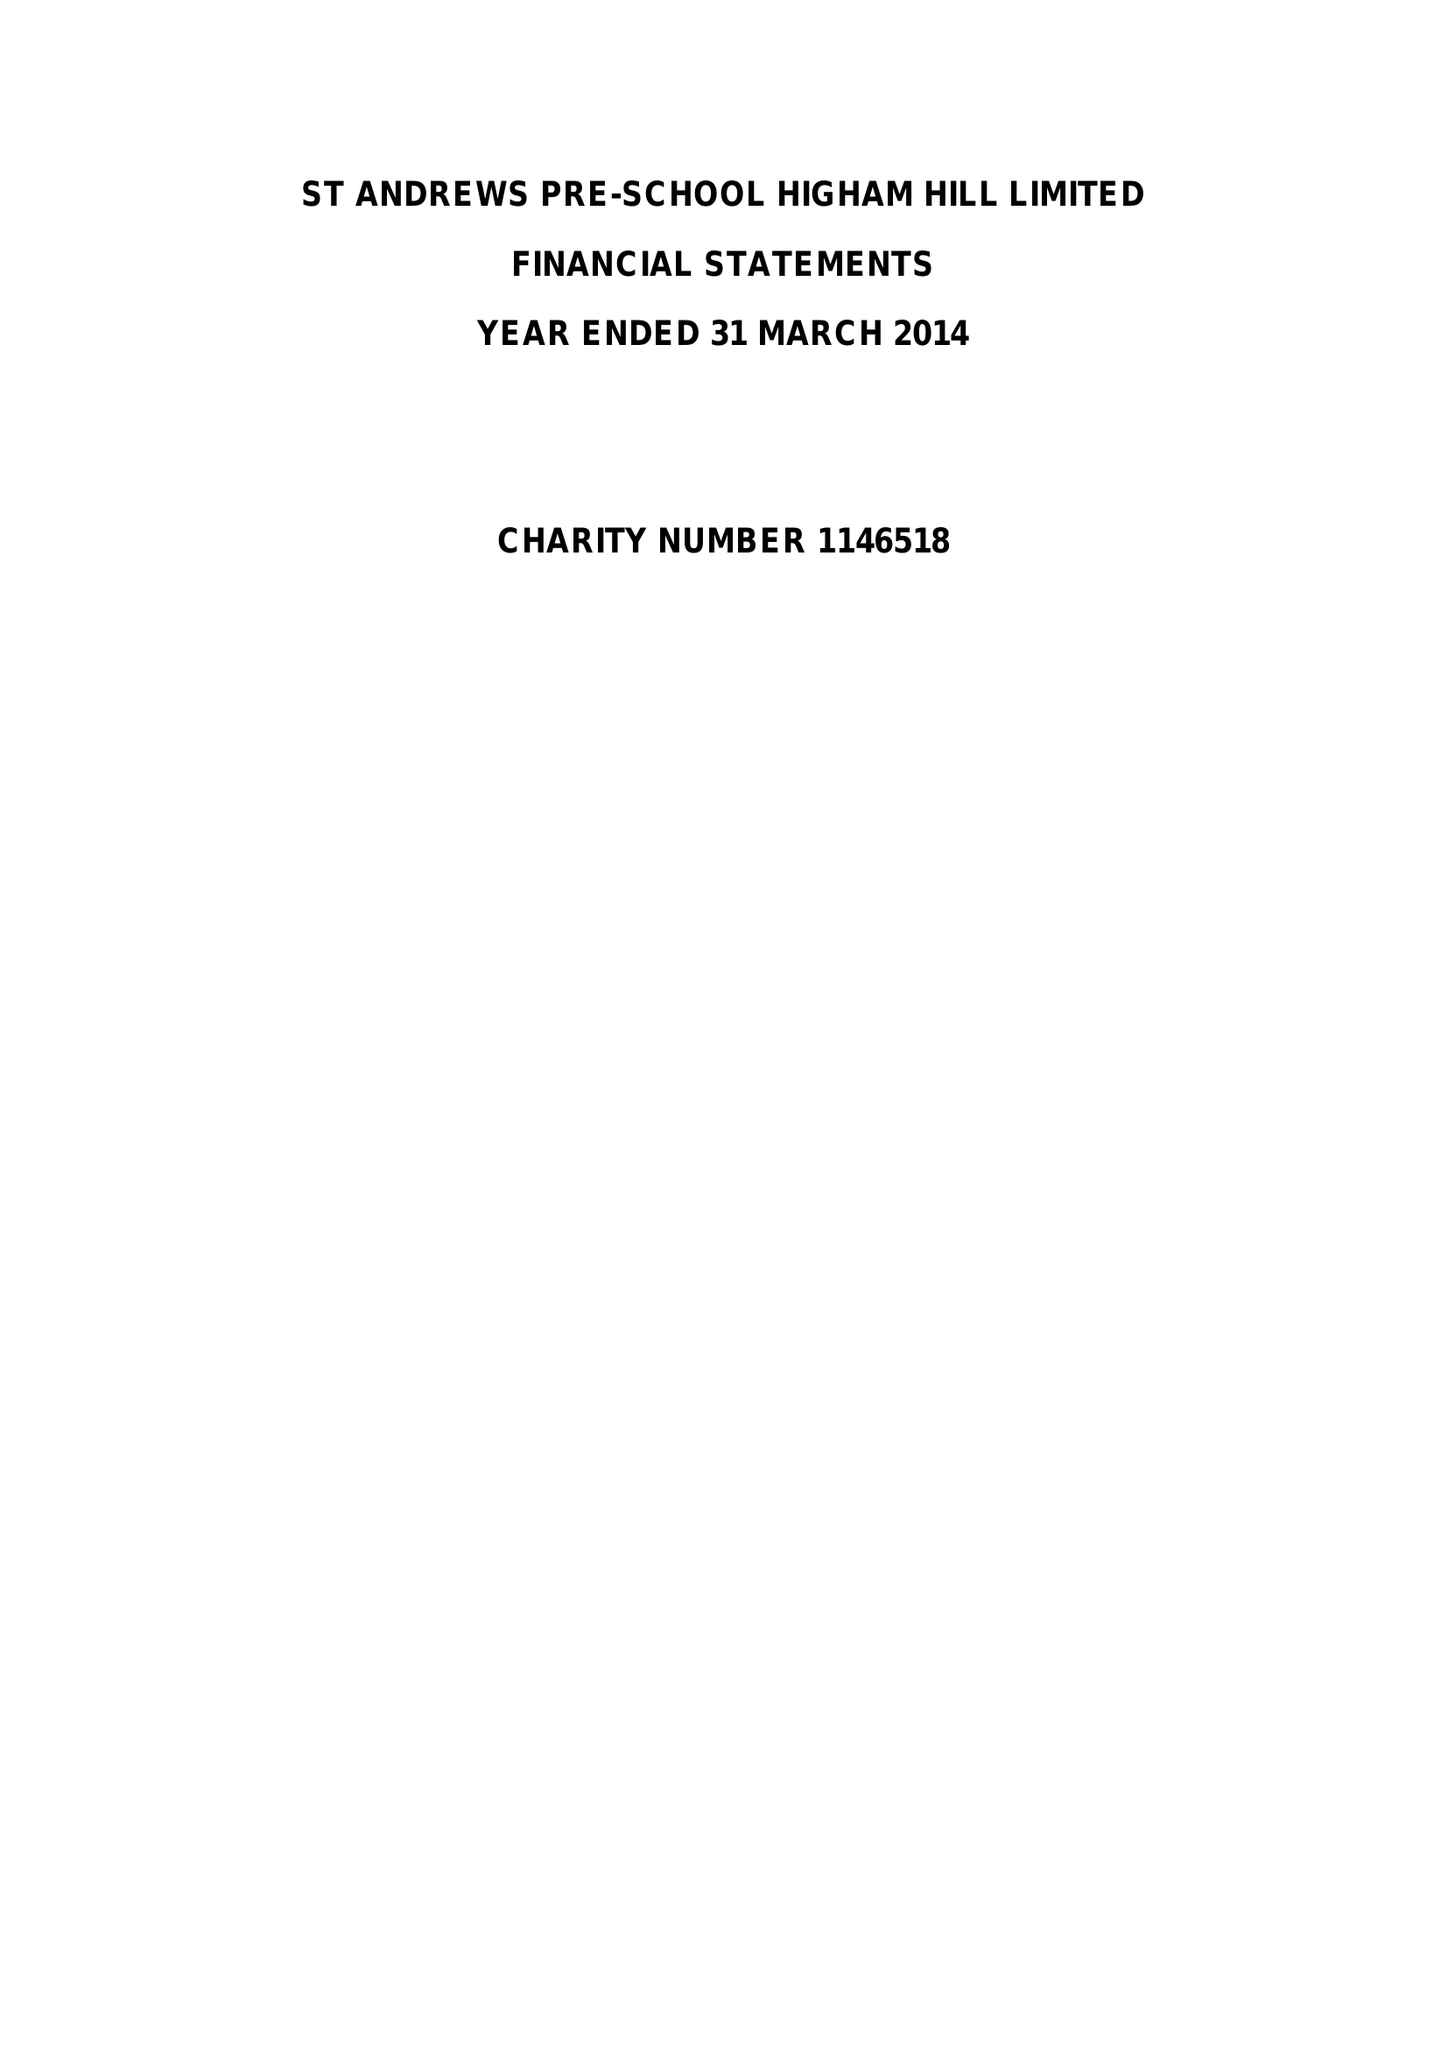What is the value for the address__post_town?
Answer the question using a single word or phrase. LONDON 